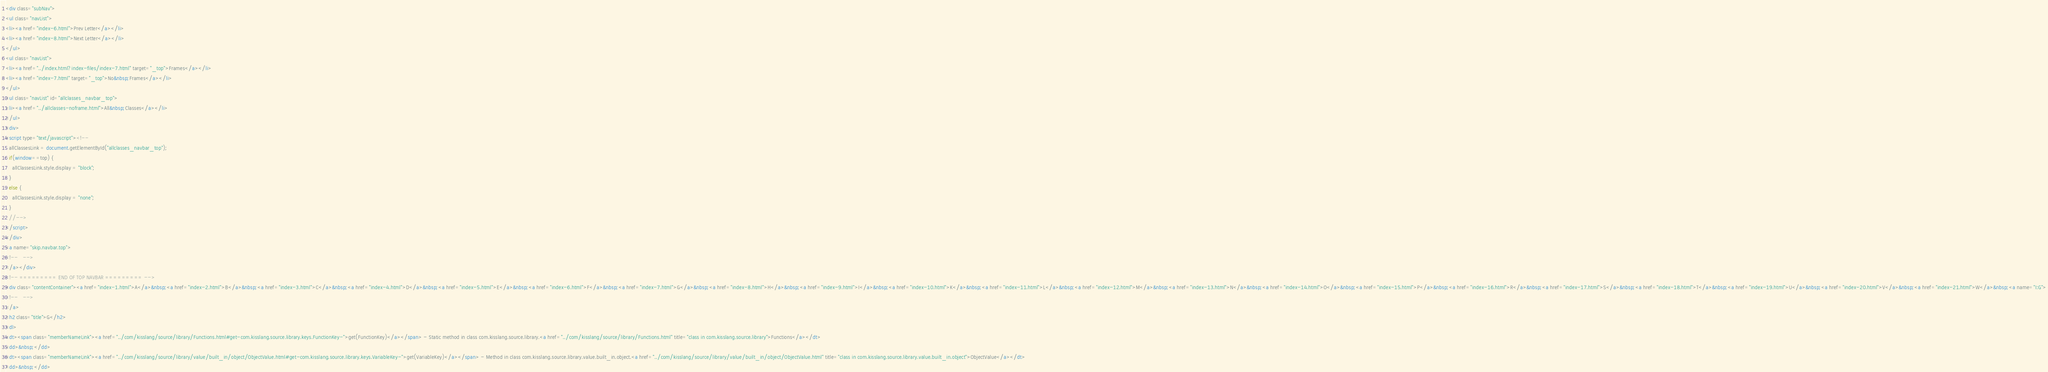<code> <loc_0><loc_0><loc_500><loc_500><_HTML_><div class="subNav">
<ul class="navList">
<li><a href="index-6.html">Prev Letter</a></li>
<li><a href="index-8.html">Next Letter</a></li>
</ul>
<ul class="navList">
<li><a href="../index.html?index-files/index-7.html" target="_top">Frames</a></li>
<li><a href="index-7.html" target="_top">No&nbsp;Frames</a></li>
</ul>
<ul class="navList" id="allclasses_navbar_top">
<li><a href="../allclasses-noframe.html">All&nbsp;Classes</a></li>
</ul>
<div>
<script type="text/javascript"><!--
  allClassesLink = document.getElementById("allclasses_navbar_top");
  if(window==top) {
    allClassesLink.style.display = "block";
  }
  else {
    allClassesLink.style.display = "none";
  }
  //-->
</script>
</div>
<a name="skip.navbar.top">
<!--   -->
</a></div>
<!-- ========= END OF TOP NAVBAR ========= -->
<div class="contentContainer"><a href="index-1.html">A</a>&nbsp;<a href="index-2.html">B</a>&nbsp;<a href="index-3.html">C</a>&nbsp;<a href="index-4.html">D</a>&nbsp;<a href="index-5.html">E</a>&nbsp;<a href="index-6.html">F</a>&nbsp;<a href="index-7.html">G</a>&nbsp;<a href="index-8.html">H</a>&nbsp;<a href="index-9.html">I</a>&nbsp;<a href="index-10.html">K</a>&nbsp;<a href="index-11.html">L</a>&nbsp;<a href="index-12.html">M</a>&nbsp;<a href="index-13.html">N</a>&nbsp;<a href="index-14.html">O</a>&nbsp;<a href="index-15.html">P</a>&nbsp;<a href="index-16.html">R</a>&nbsp;<a href="index-17.html">S</a>&nbsp;<a href="index-18.html">T</a>&nbsp;<a href="index-19.html">U</a>&nbsp;<a href="index-20.html">V</a>&nbsp;<a href="index-21.html">W</a>&nbsp;<a name="I:G">
<!--   -->
</a>
<h2 class="title">G</h2>
<dl>
<dt><span class="memberNameLink"><a href="../com/kisslang/source/library/Functions.html#get-com.kisslang.source.library.keys.FunctionKey-">get(FunctionKey)</a></span> - Static method in class com.kisslang.source.library.<a href="../com/kisslang/source/library/Functions.html" title="class in com.kisslang.source.library">Functions</a></dt>
<dd>&nbsp;</dd>
<dt><span class="memberNameLink"><a href="../com/kisslang/source/library/value/built_in/object/ObjectValue.html#get-com.kisslang.source.library.keys.VariableKey-">get(VariableKey)</a></span> - Method in class com.kisslang.source.library.value.built_in.object.<a href="../com/kisslang/source/library/value/built_in/object/ObjectValue.html" title="class in com.kisslang.source.library.value.built_in.object">ObjectValue</a></dt>
<dd>&nbsp;</dd></code> 